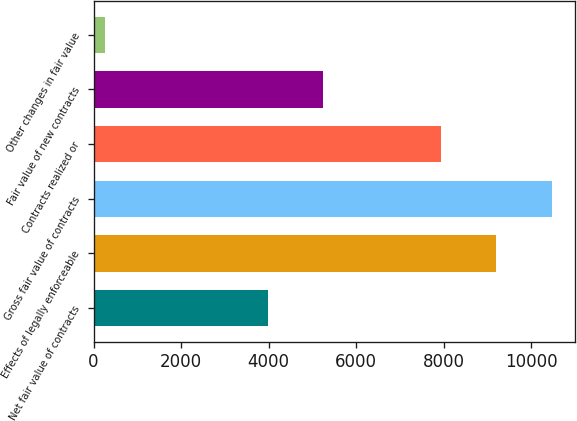Convert chart. <chart><loc_0><loc_0><loc_500><loc_500><bar_chart><fcel>Net fair value of contracts<fcel>Effects of legally enforceable<fcel>Gross fair value of contracts<fcel>Contracts realized or<fcel>Fair value of new contracts<fcel>Other changes in fair value<nl><fcel>3977<fcel>9197.9<fcel>10469.8<fcel>7926<fcel>5248.9<fcel>265<nl></chart> 